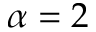Convert formula to latex. <formula><loc_0><loc_0><loc_500><loc_500>\alpha = 2</formula> 